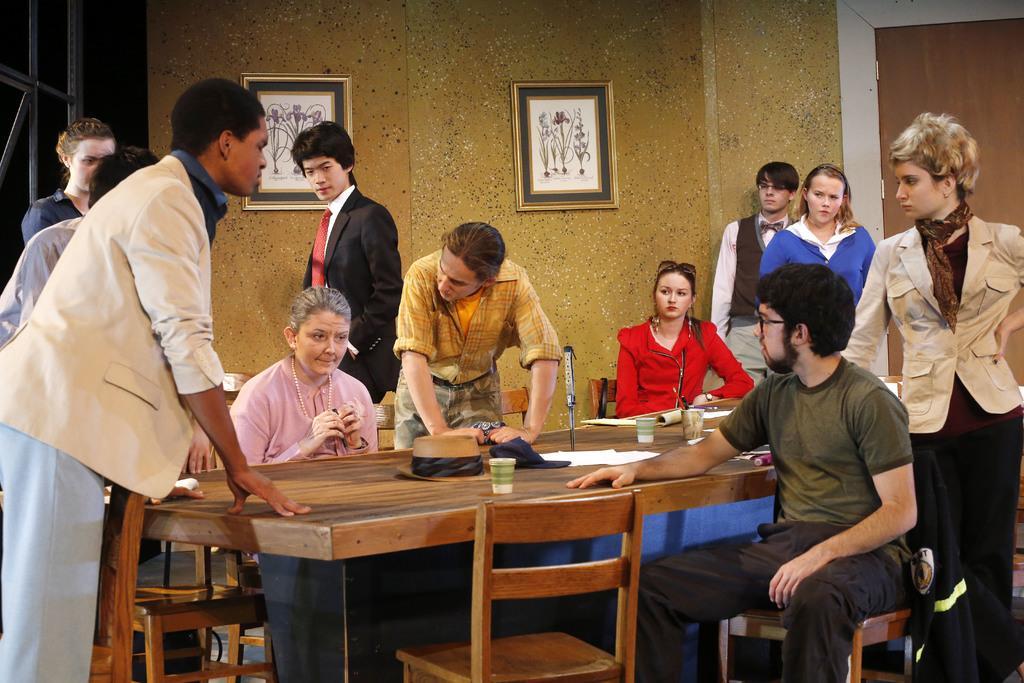How would you summarize this image in a sentence or two? In this image there are three person sitting on the chair. On the table there is a cup,hat and a paper. Few people are standing around. At the background there is a frame attached to the wall. 